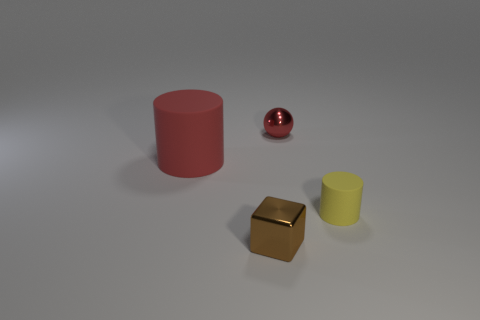Add 2 big red matte cylinders. How many objects exist? 6 Add 1 tiny green cylinders. How many tiny green cylinders exist? 1 Subtract 0 yellow cubes. How many objects are left? 4 Subtract all red shiny spheres. Subtract all red spheres. How many objects are left? 2 Add 2 tiny brown blocks. How many tiny brown blocks are left? 3 